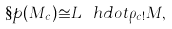<formula> <loc_0><loc_0><loc_500><loc_500>\S p ( M _ { c } ) \cong L ^ { \ } h d o t \rho _ { c ! } M ,</formula> 